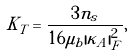<formula> <loc_0><loc_0><loc_500><loc_500>K _ { T } = \frac { 3 n _ { s } } { 1 6 \mu _ { b } | \kappa _ { A } | ^ { 2 } _ { F } } ,</formula> 